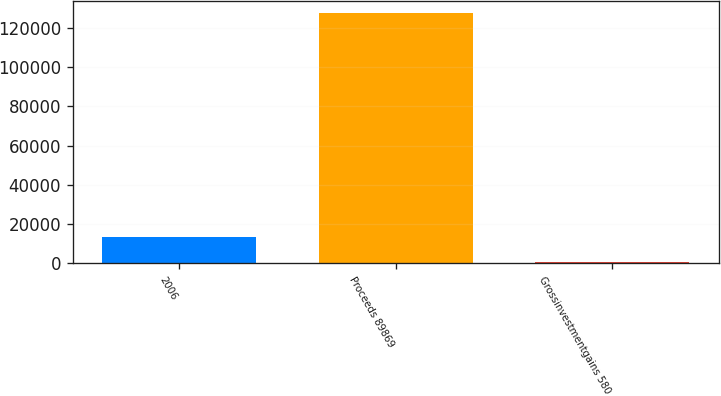<chart> <loc_0><loc_0><loc_500><loc_500><bar_chart><fcel>2006<fcel>Proceeds 89869<fcel>Grossinvestmentgains 580<nl><fcel>13404.5<fcel>127709<fcel>704<nl></chart> 